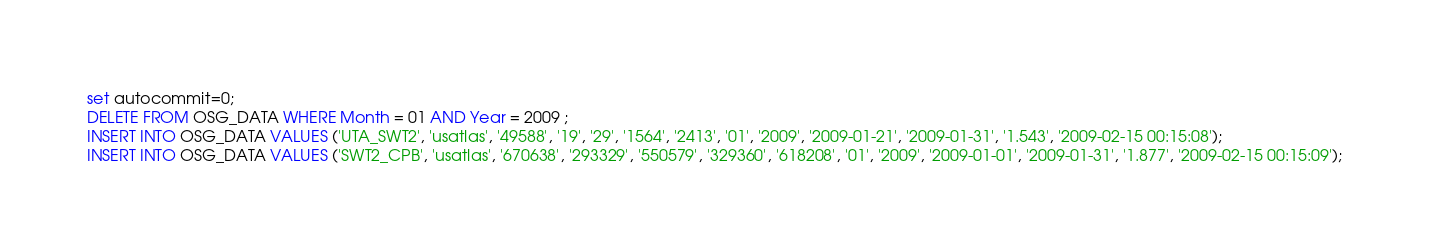<code> <loc_0><loc_0><loc_500><loc_500><_SQL_>set autocommit=0;
DELETE FROM OSG_DATA WHERE Month = 01 AND Year = 2009 ;
INSERT INTO OSG_DATA VALUES ('UTA_SWT2', 'usatlas', '49588', '19', '29', '1564', '2413', '01', '2009', '2009-01-21', '2009-01-31', '1.543', '2009-02-15 00:15:08');
INSERT INTO OSG_DATA VALUES ('SWT2_CPB', 'usatlas', '670638', '293329', '550579', '329360', '618208', '01', '2009', '2009-01-01', '2009-01-31', '1.877', '2009-02-15 00:15:09');</code> 